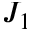Convert formula to latex. <formula><loc_0><loc_0><loc_500><loc_500>J _ { 1 }</formula> 